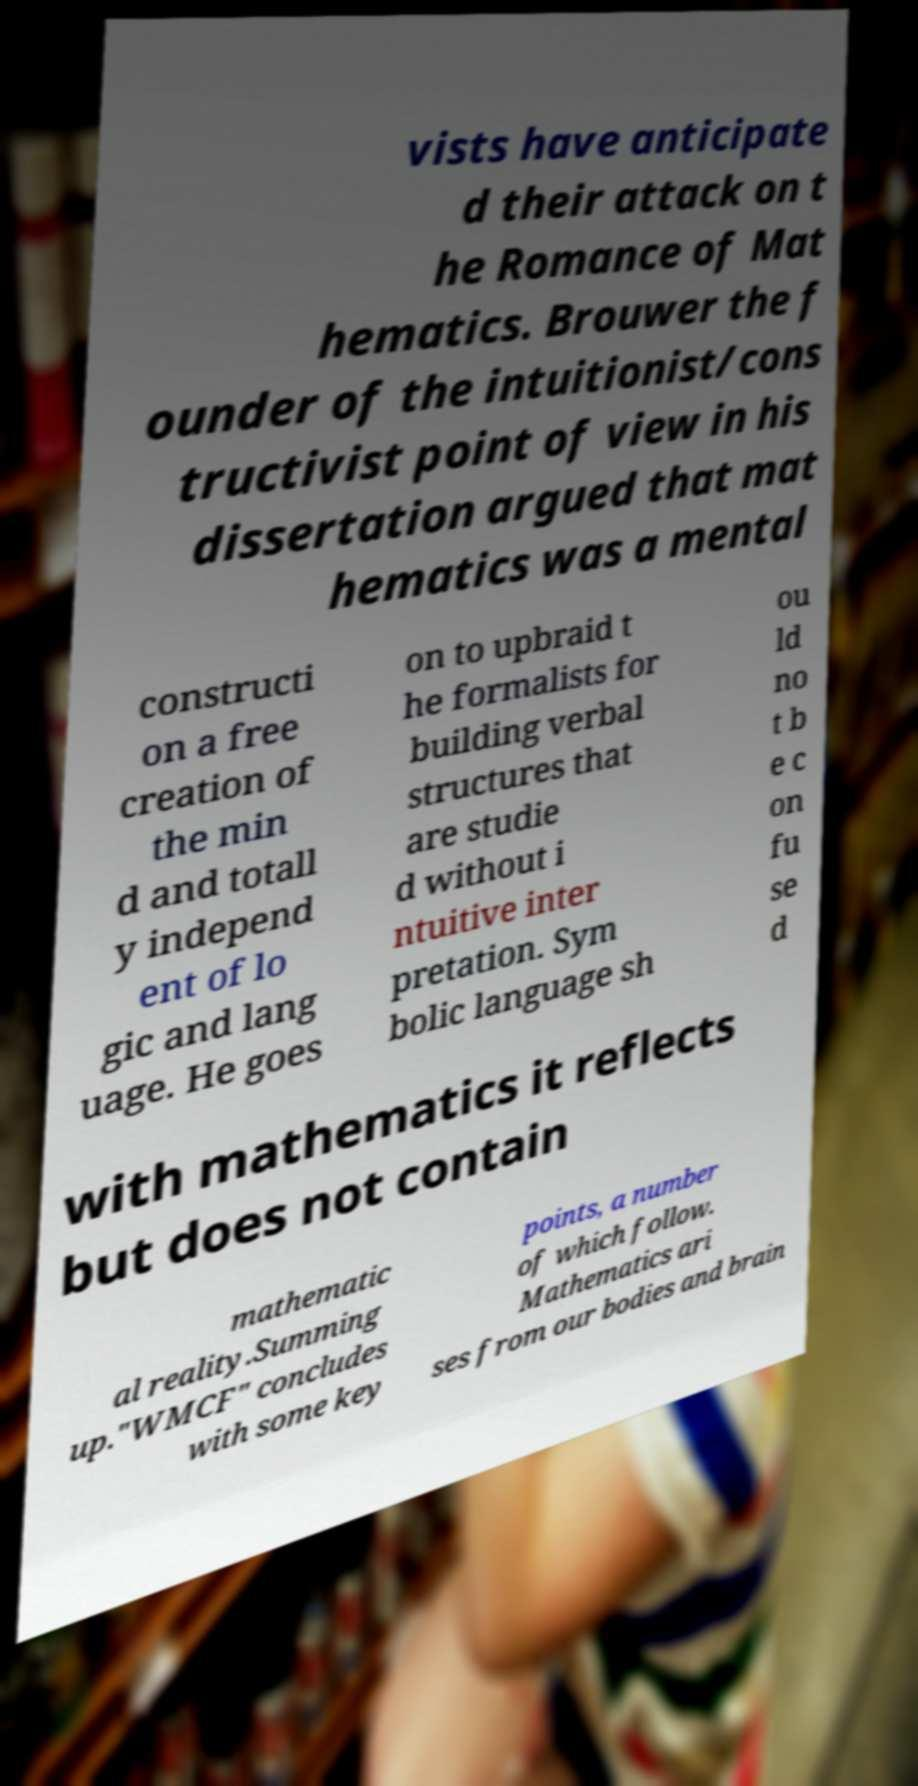Can you read and provide the text displayed in the image?This photo seems to have some interesting text. Can you extract and type it out for me? vists have anticipate d their attack on t he Romance of Mat hematics. Brouwer the f ounder of the intuitionist/cons tructivist point of view in his dissertation argued that mat hematics was a mental constructi on a free creation of the min d and totall y independ ent of lo gic and lang uage. He goes on to upbraid t he formalists for building verbal structures that are studie d without i ntuitive inter pretation. Sym bolic language sh ou ld no t b e c on fu se d with mathematics it reflects but does not contain mathematic al reality.Summing up."WMCF" concludes with some key points, a number of which follow. Mathematics ari ses from our bodies and brain 